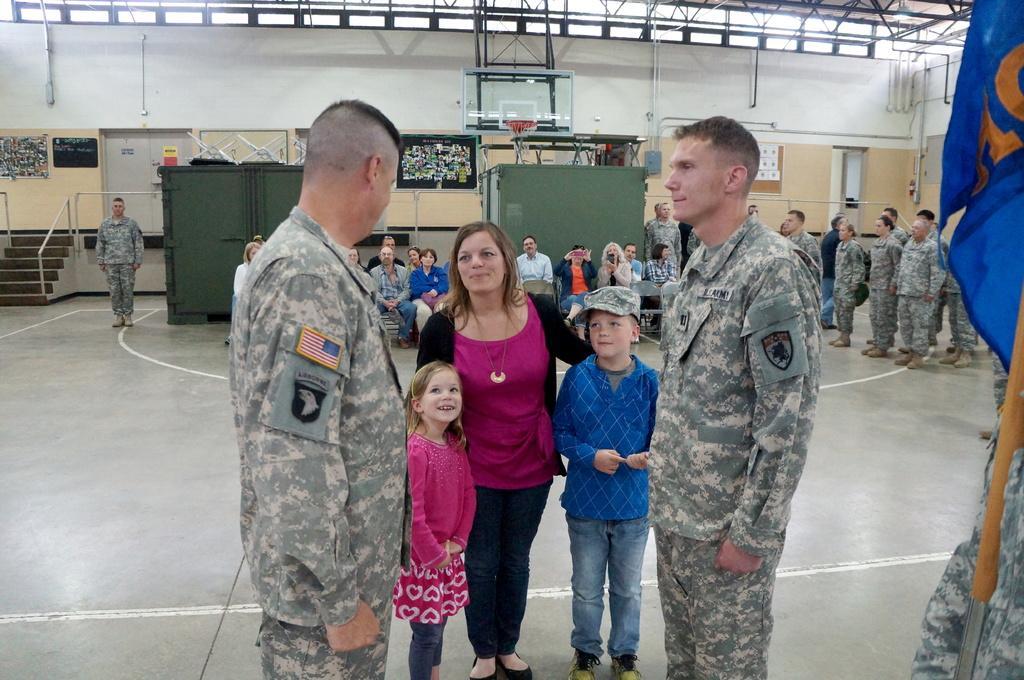Please provide a concise description of this image. In this picture we can see a group of people on the ground,some people are sitting,some people are standing and in the background we can see a wall. 